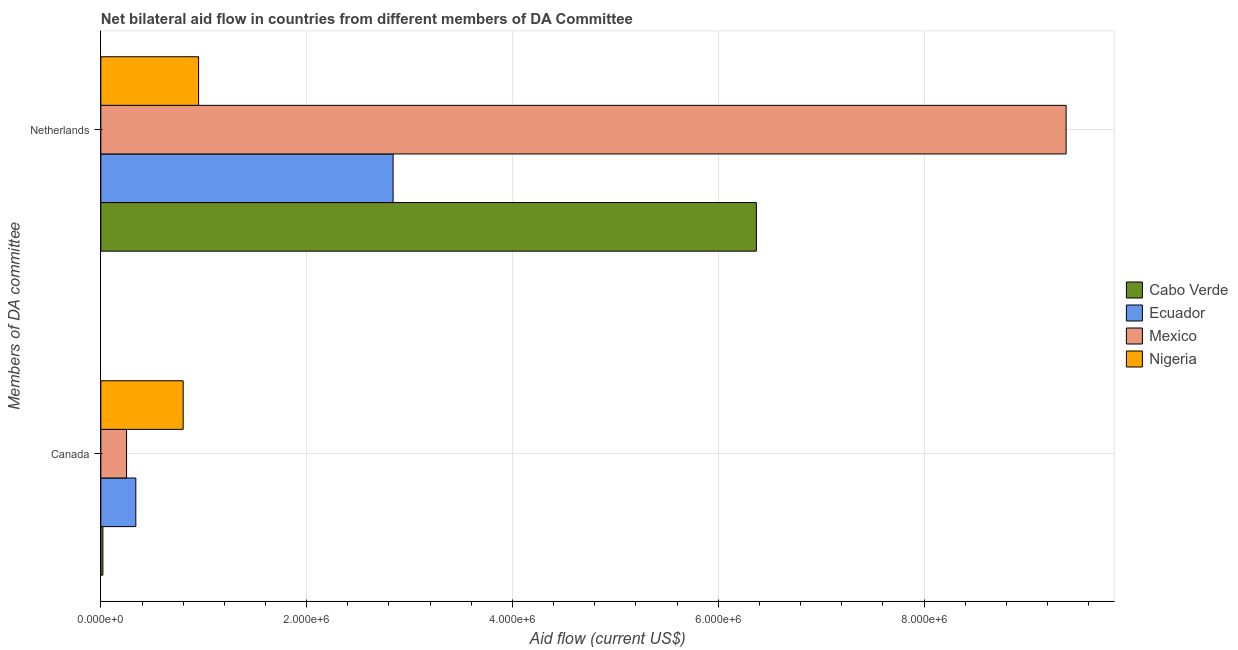How many different coloured bars are there?
Provide a succinct answer. 4. How many groups of bars are there?
Your answer should be very brief. 2. Are the number of bars per tick equal to the number of legend labels?
Offer a very short reply. Yes. Are the number of bars on each tick of the Y-axis equal?
Ensure brevity in your answer.  Yes. What is the amount of aid given by canada in Ecuador?
Provide a short and direct response. 3.40e+05. Across all countries, what is the maximum amount of aid given by netherlands?
Keep it short and to the point. 9.38e+06. Across all countries, what is the minimum amount of aid given by canada?
Offer a very short reply. 2.00e+04. In which country was the amount of aid given by canada minimum?
Make the answer very short. Cabo Verde. What is the total amount of aid given by netherlands in the graph?
Provide a succinct answer. 1.95e+07. What is the difference between the amount of aid given by netherlands in Ecuador and that in Mexico?
Give a very brief answer. -6.54e+06. What is the difference between the amount of aid given by netherlands in Mexico and the amount of aid given by canada in Ecuador?
Provide a succinct answer. 9.04e+06. What is the average amount of aid given by canada per country?
Your answer should be compact. 3.52e+05. What is the difference between the amount of aid given by canada and amount of aid given by netherlands in Ecuador?
Your answer should be very brief. -2.50e+06. What is the ratio of the amount of aid given by netherlands in Nigeria to that in Mexico?
Give a very brief answer. 0.1. In how many countries, is the amount of aid given by netherlands greater than the average amount of aid given by netherlands taken over all countries?
Your answer should be compact. 2. What does the 4th bar from the top in Netherlands represents?
Give a very brief answer. Cabo Verde. What does the 1st bar from the bottom in Netherlands represents?
Your answer should be very brief. Cabo Verde. How many bars are there?
Your answer should be compact. 8. How many countries are there in the graph?
Keep it short and to the point. 4. What is the difference between two consecutive major ticks on the X-axis?
Provide a succinct answer. 2.00e+06. Does the graph contain any zero values?
Your answer should be very brief. No. How many legend labels are there?
Offer a very short reply. 4. How are the legend labels stacked?
Your answer should be compact. Vertical. What is the title of the graph?
Your response must be concise. Net bilateral aid flow in countries from different members of DA Committee. What is the label or title of the Y-axis?
Make the answer very short. Members of DA committee. What is the Aid flow (current US$) of Cabo Verde in Canada?
Make the answer very short. 2.00e+04. What is the Aid flow (current US$) of Mexico in Canada?
Your response must be concise. 2.50e+05. What is the Aid flow (current US$) of Cabo Verde in Netherlands?
Your answer should be very brief. 6.37e+06. What is the Aid flow (current US$) of Ecuador in Netherlands?
Ensure brevity in your answer.  2.84e+06. What is the Aid flow (current US$) in Mexico in Netherlands?
Offer a very short reply. 9.38e+06. What is the Aid flow (current US$) in Nigeria in Netherlands?
Make the answer very short. 9.50e+05. Across all Members of DA committee, what is the maximum Aid flow (current US$) in Cabo Verde?
Your response must be concise. 6.37e+06. Across all Members of DA committee, what is the maximum Aid flow (current US$) of Ecuador?
Provide a short and direct response. 2.84e+06. Across all Members of DA committee, what is the maximum Aid flow (current US$) of Mexico?
Offer a terse response. 9.38e+06. Across all Members of DA committee, what is the maximum Aid flow (current US$) in Nigeria?
Your answer should be compact. 9.50e+05. Across all Members of DA committee, what is the minimum Aid flow (current US$) of Ecuador?
Provide a short and direct response. 3.40e+05. Across all Members of DA committee, what is the minimum Aid flow (current US$) in Mexico?
Provide a short and direct response. 2.50e+05. What is the total Aid flow (current US$) in Cabo Verde in the graph?
Offer a terse response. 6.39e+06. What is the total Aid flow (current US$) in Ecuador in the graph?
Make the answer very short. 3.18e+06. What is the total Aid flow (current US$) of Mexico in the graph?
Make the answer very short. 9.63e+06. What is the total Aid flow (current US$) in Nigeria in the graph?
Offer a terse response. 1.75e+06. What is the difference between the Aid flow (current US$) in Cabo Verde in Canada and that in Netherlands?
Offer a very short reply. -6.35e+06. What is the difference between the Aid flow (current US$) in Ecuador in Canada and that in Netherlands?
Offer a very short reply. -2.50e+06. What is the difference between the Aid flow (current US$) in Mexico in Canada and that in Netherlands?
Ensure brevity in your answer.  -9.13e+06. What is the difference between the Aid flow (current US$) in Nigeria in Canada and that in Netherlands?
Ensure brevity in your answer.  -1.50e+05. What is the difference between the Aid flow (current US$) of Cabo Verde in Canada and the Aid flow (current US$) of Ecuador in Netherlands?
Provide a succinct answer. -2.82e+06. What is the difference between the Aid flow (current US$) in Cabo Verde in Canada and the Aid flow (current US$) in Mexico in Netherlands?
Your answer should be very brief. -9.36e+06. What is the difference between the Aid flow (current US$) of Cabo Verde in Canada and the Aid flow (current US$) of Nigeria in Netherlands?
Offer a very short reply. -9.30e+05. What is the difference between the Aid flow (current US$) of Ecuador in Canada and the Aid flow (current US$) of Mexico in Netherlands?
Your answer should be compact. -9.04e+06. What is the difference between the Aid flow (current US$) in Ecuador in Canada and the Aid flow (current US$) in Nigeria in Netherlands?
Keep it short and to the point. -6.10e+05. What is the difference between the Aid flow (current US$) of Mexico in Canada and the Aid flow (current US$) of Nigeria in Netherlands?
Ensure brevity in your answer.  -7.00e+05. What is the average Aid flow (current US$) of Cabo Verde per Members of DA committee?
Give a very brief answer. 3.20e+06. What is the average Aid flow (current US$) of Ecuador per Members of DA committee?
Ensure brevity in your answer.  1.59e+06. What is the average Aid flow (current US$) of Mexico per Members of DA committee?
Your response must be concise. 4.82e+06. What is the average Aid flow (current US$) of Nigeria per Members of DA committee?
Ensure brevity in your answer.  8.75e+05. What is the difference between the Aid flow (current US$) of Cabo Verde and Aid flow (current US$) of Ecuador in Canada?
Keep it short and to the point. -3.20e+05. What is the difference between the Aid flow (current US$) of Cabo Verde and Aid flow (current US$) of Nigeria in Canada?
Give a very brief answer. -7.80e+05. What is the difference between the Aid flow (current US$) of Ecuador and Aid flow (current US$) of Mexico in Canada?
Provide a short and direct response. 9.00e+04. What is the difference between the Aid flow (current US$) of Ecuador and Aid flow (current US$) of Nigeria in Canada?
Your answer should be compact. -4.60e+05. What is the difference between the Aid flow (current US$) in Mexico and Aid flow (current US$) in Nigeria in Canada?
Offer a terse response. -5.50e+05. What is the difference between the Aid flow (current US$) in Cabo Verde and Aid flow (current US$) in Ecuador in Netherlands?
Offer a terse response. 3.53e+06. What is the difference between the Aid flow (current US$) in Cabo Verde and Aid flow (current US$) in Mexico in Netherlands?
Make the answer very short. -3.01e+06. What is the difference between the Aid flow (current US$) in Cabo Verde and Aid flow (current US$) in Nigeria in Netherlands?
Your answer should be very brief. 5.42e+06. What is the difference between the Aid flow (current US$) in Ecuador and Aid flow (current US$) in Mexico in Netherlands?
Ensure brevity in your answer.  -6.54e+06. What is the difference between the Aid flow (current US$) of Ecuador and Aid flow (current US$) of Nigeria in Netherlands?
Give a very brief answer. 1.89e+06. What is the difference between the Aid flow (current US$) of Mexico and Aid flow (current US$) of Nigeria in Netherlands?
Ensure brevity in your answer.  8.43e+06. What is the ratio of the Aid flow (current US$) of Cabo Verde in Canada to that in Netherlands?
Your answer should be compact. 0. What is the ratio of the Aid flow (current US$) of Ecuador in Canada to that in Netherlands?
Give a very brief answer. 0.12. What is the ratio of the Aid flow (current US$) of Mexico in Canada to that in Netherlands?
Keep it short and to the point. 0.03. What is the ratio of the Aid flow (current US$) in Nigeria in Canada to that in Netherlands?
Your answer should be very brief. 0.84. What is the difference between the highest and the second highest Aid flow (current US$) of Cabo Verde?
Keep it short and to the point. 6.35e+06. What is the difference between the highest and the second highest Aid flow (current US$) of Ecuador?
Your answer should be very brief. 2.50e+06. What is the difference between the highest and the second highest Aid flow (current US$) in Mexico?
Provide a succinct answer. 9.13e+06. What is the difference between the highest and the lowest Aid flow (current US$) of Cabo Verde?
Your response must be concise. 6.35e+06. What is the difference between the highest and the lowest Aid flow (current US$) in Ecuador?
Provide a succinct answer. 2.50e+06. What is the difference between the highest and the lowest Aid flow (current US$) in Mexico?
Offer a terse response. 9.13e+06. 